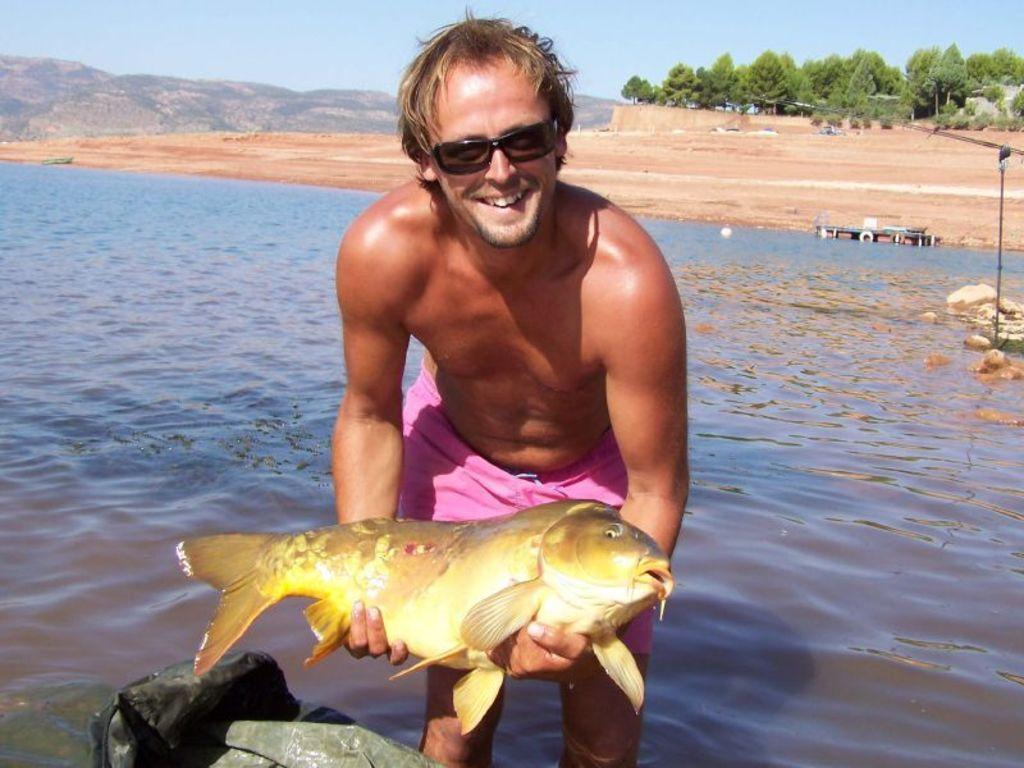What is present in the image that is not solid? There is water in the image. What is the man in the image holding? The man is holding a fish in the image. What type of objects can be seen on the ground in the image? There are stones in the image. What type of landscape feature is visible in the image? There is a hill in the image. What type of vegetation is visible in the background of the image? There are trees in the background of the image. What is visible at the top of the image? The sky is visible at the top of the image. What type of can is visible in the image? There is no can present in the image. What color is the powder on the hill in the image? There is no powder present in the image. 